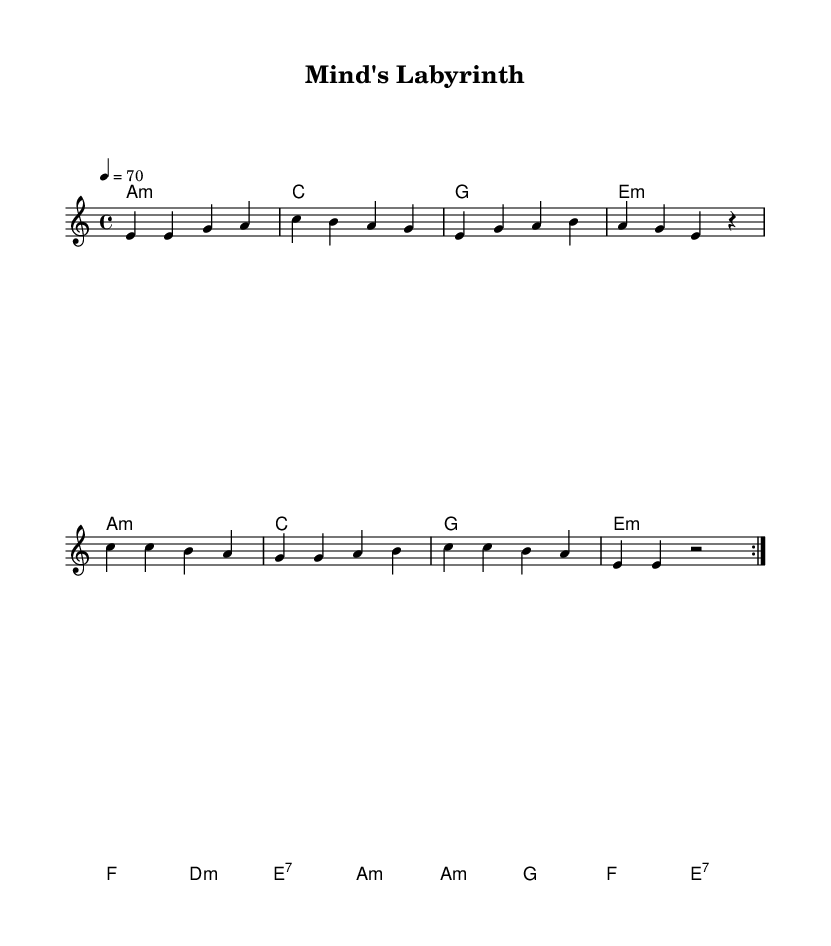What is the key signature of this music? The key signature is A minor, which features no sharps or flats. A minor is the relative minor of C major.
Answer: A minor What is the time signature of this music? The time signature shown is 4/4, meaning there are four beats per measure, and the quarter note receives one beat.
Answer: 4/4 What is the tempo of this composition? The tempo marking indicates a speed of 70 beats per minute, suggesting a moderate pace for the performance.
Answer: 70 How many measures are in the verse section? The verse section is repeated twice, and consists of four measures; therefore, there are a total of eight measures in the verse when repeated.
Answer: 8 What chord follows A minor in the harmony section? Following A minor, the next chord in the harmony sequence is C major as indicated in the chord changes.
Answer: C What notable chord is used at the end of the harmony section? The last chord in the harmony section is E7, which is a dominant seventh chord commonly used to create tension before resolving back to A minor.
Answer: E7 How does this music reflect the characteristics of Electric Blues? The use of minor chords, expressive melodies, and a repetitive structure that explores deep emotions enhances its connection to Electric Blues, which often reflects personal feelings and struggles.
Answer: Introspective 